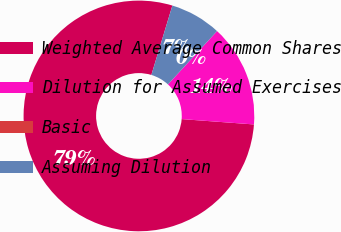<chart> <loc_0><loc_0><loc_500><loc_500><pie_chart><fcel>Weighted Average Common Shares<fcel>Dilution for Assumed Exercises<fcel>Basic<fcel>Assuming Dilution<nl><fcel>78.51%<fcel>14.33%<fcel>0.0%<fcel>7.16%<nl></chart> 